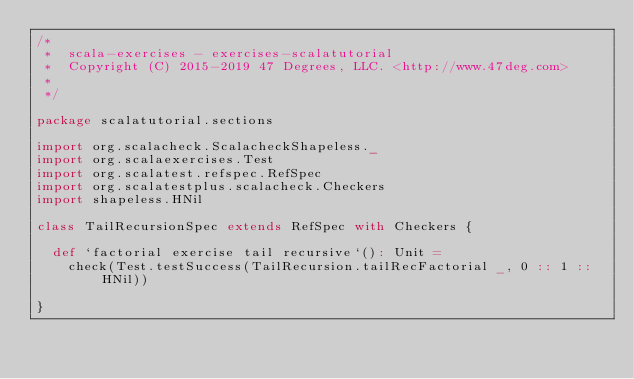Convert code to text. <code><loc_0><loc_0><loc_500><loc_500><_Scala_>/*
 *  scala-exercises - exercises-scalatutorial
 *  Copyright (C) 2015-2019 47 Degrees, LLC. <http://www.47deg.com>
 *
 */

package scalatutorial.sections

import org.scalacheck.ScalacheckShapeless._
import org.scalaexercises.Test
import org.scalatest.refspec.RefSpec
import org.scalatestplus.scalacheck.Checkers
import shapeless.HNil

class TailRecursionSpec extends RefSpec with Checkers {

  def `factorial exercise tail recursive`(): Unit =
    check(Test.testSuccess(TailRecursion.tailRecFactorial _, 0 :: 1 :: HNil))

}
</code> 